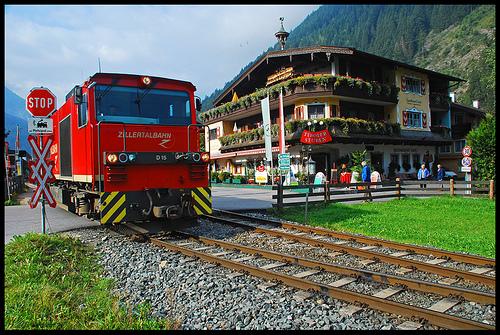Are the police about to pull over this vehicle for a traffic violation?
Short answer required. No. What's the name painted on the front of the locomotive?
Give a very brief answer. Zillertalbahn. What color is the train?
Concise answer only. Red. How many people are visible in the photo?
Answer briefly. 3. Does this train have electronic components that assist its engineer?
Concise answer only. Yes. Is the train at the station?
Concise answer only. No. Is the train moving through a city?
Give a very brief answer. Yes. How many train cars are there?
Short answer required. 1. Is this train in the middle of a city?
Concise answer only. Yes. Is this a still or moving picture?
Short answer required. Still. What number is the train?
Keep it brief. 25. Is the train closer than the brown building?
Keep it brief. Yes. Is this a traditional stop sign?
Quick response, please. Yes. What does this train use to propel it?
Quick response, please. Coal. 